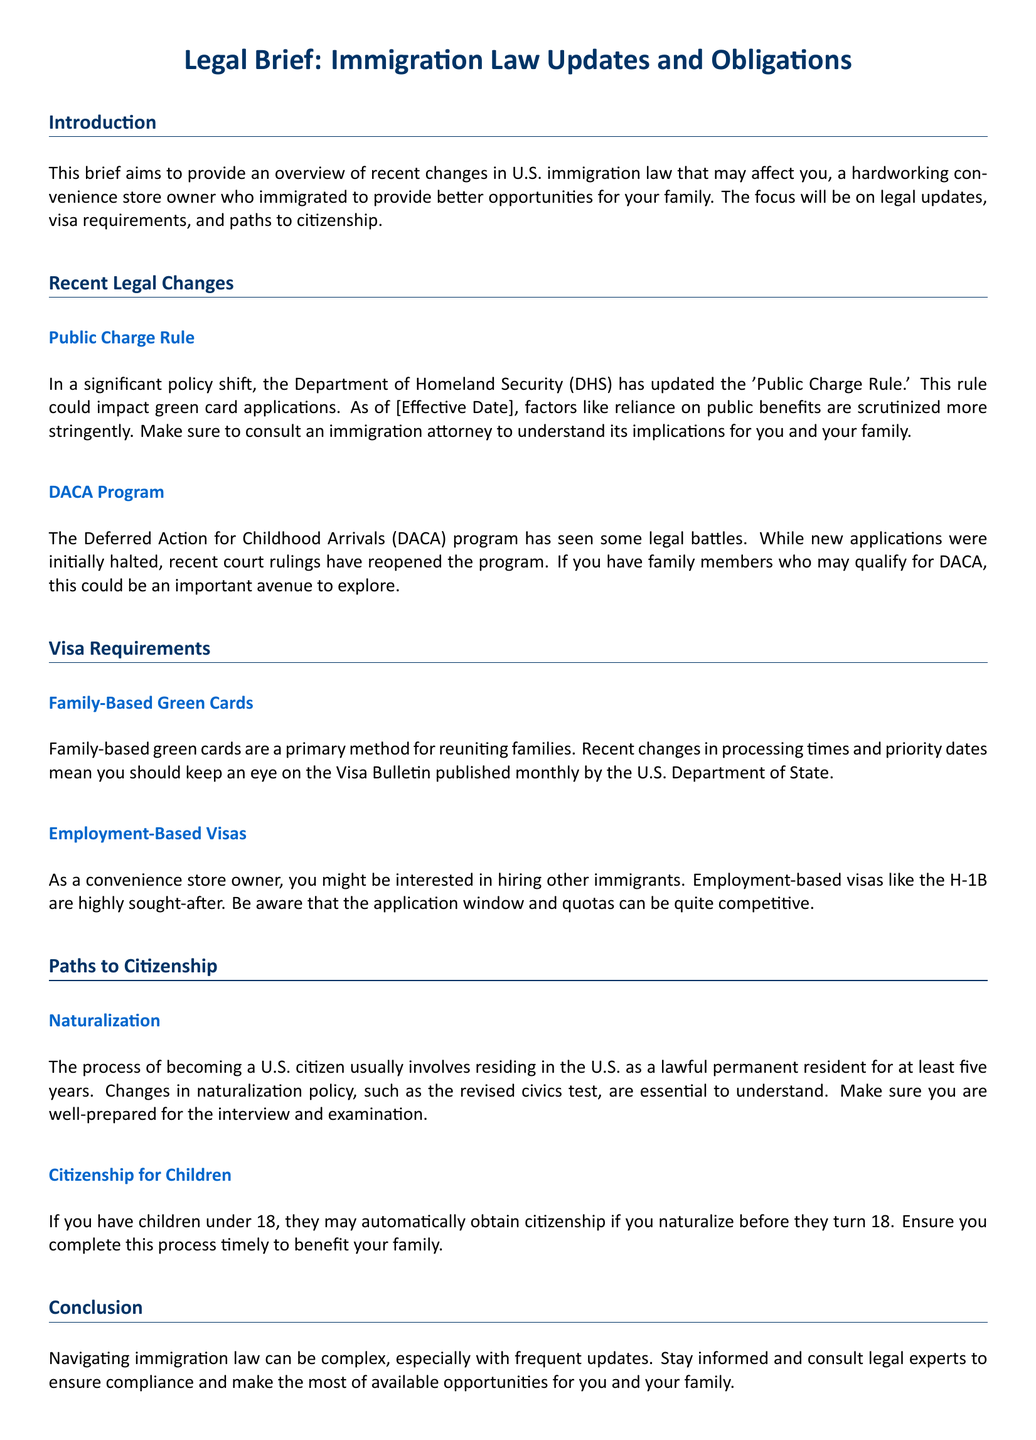What is the title of the document? The title of the document is presented prominently at the beginning, identifying its focus and content.
Answer: Legal Brief: Immigration Law Updates and Obligations What is the effective date mentioned in the Public Charge Rule section? The specific effective date is intended to highlight when the rule changes take effect, but it is placeholders in the text.
Answer: [Effective Date] What program could family members qualify for according to the DACA Program section? This program is mentioned as a potential opportunity for certain individuals, particularly in the context of family circumstances.
Answer: DACA How long do lawful permanent residents usually need to reside in the U.S. before applying for naturalization? This duration is specified to help immigrants understand the time required for citizenship eligibility.
Answer: five years What type of visa is mentioned for those looking to hire other immigrants? The document specifies a type of visa relevant to employment opportunities for immigrants.
Answer: H-1B What may automatically happen to children if a parent naturalizes before they turn 18? This outcome is outlined to emphasize the familial benefits of the naturalization process.
Answer: citizenship What document should you keep an eye on for family-based green card processing times? This document is recommended for tracking important visa information relevant to family matters.
Answer: Visa Bulletin What are applicants encouraged to do in preparation for the naturalization process? This recommendation is crucial for ensuring readiness for a key step in obtaining citizenship.
Answer: be well-prepared What does the introduction primarily aim to provide an overview of? The introduction establishes the document's focus by outlining the main subject matter covered within it.
Answer: recent changes in U.S. immigration law 